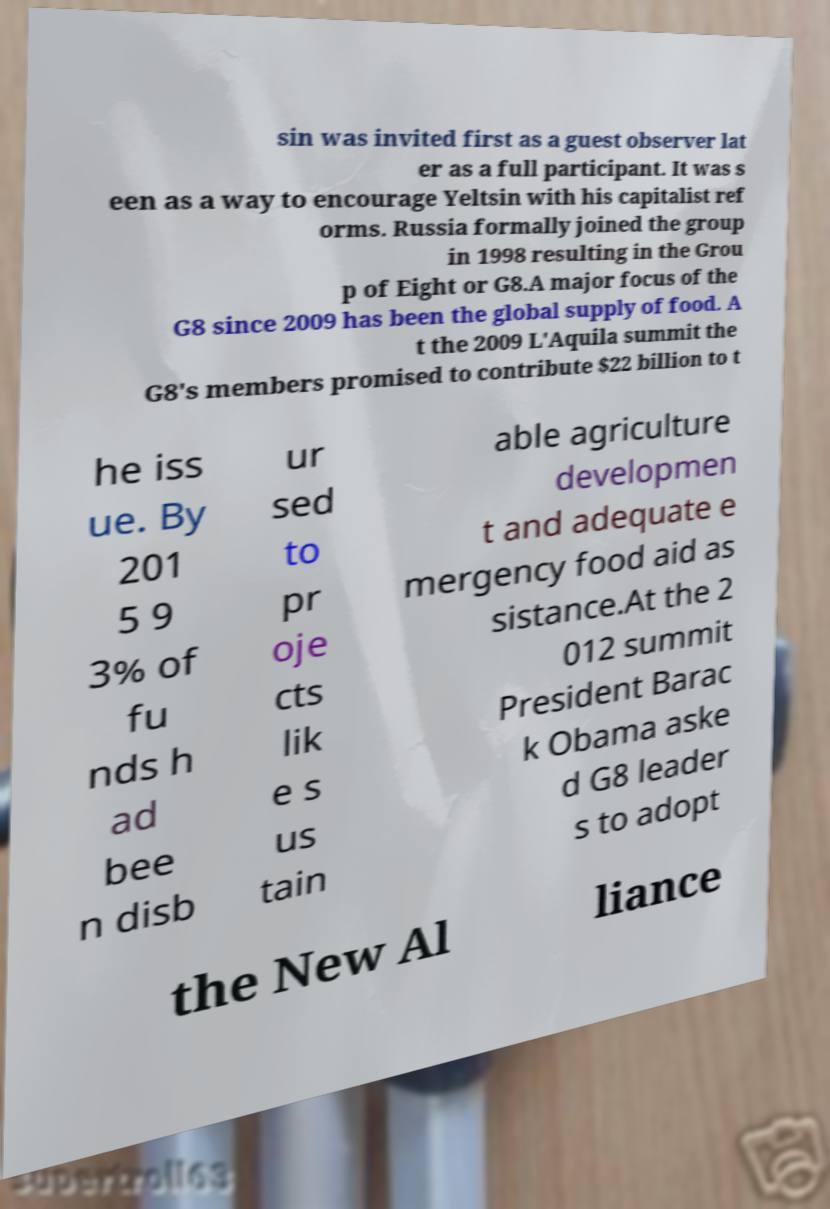Could you assist in decoding the text presented in this image and type it out clearly? sin was invited first as a guest observer lat er as a full participant. It was s een as a way to encourage Yeltsin with his capitalist ref orms. Russia formally joined the group in 1998 resulting in the Grou p of Eight or G8.A major focus of the G8 since 2009 has been the global supply of food. A t the 2009 L'Aquila summit the G8's members promised to contribute $22 billion to t he iss ue. By 201 5 9 3% of fu nds h ad bee n disb ur sed to pr oje cts lik e s us tain able agriculture developmen t and adequate e mergency food aid as sistance.At the 2 012 summit President Barac k Obama aske d G8 leader s to adopt the New Al liance 